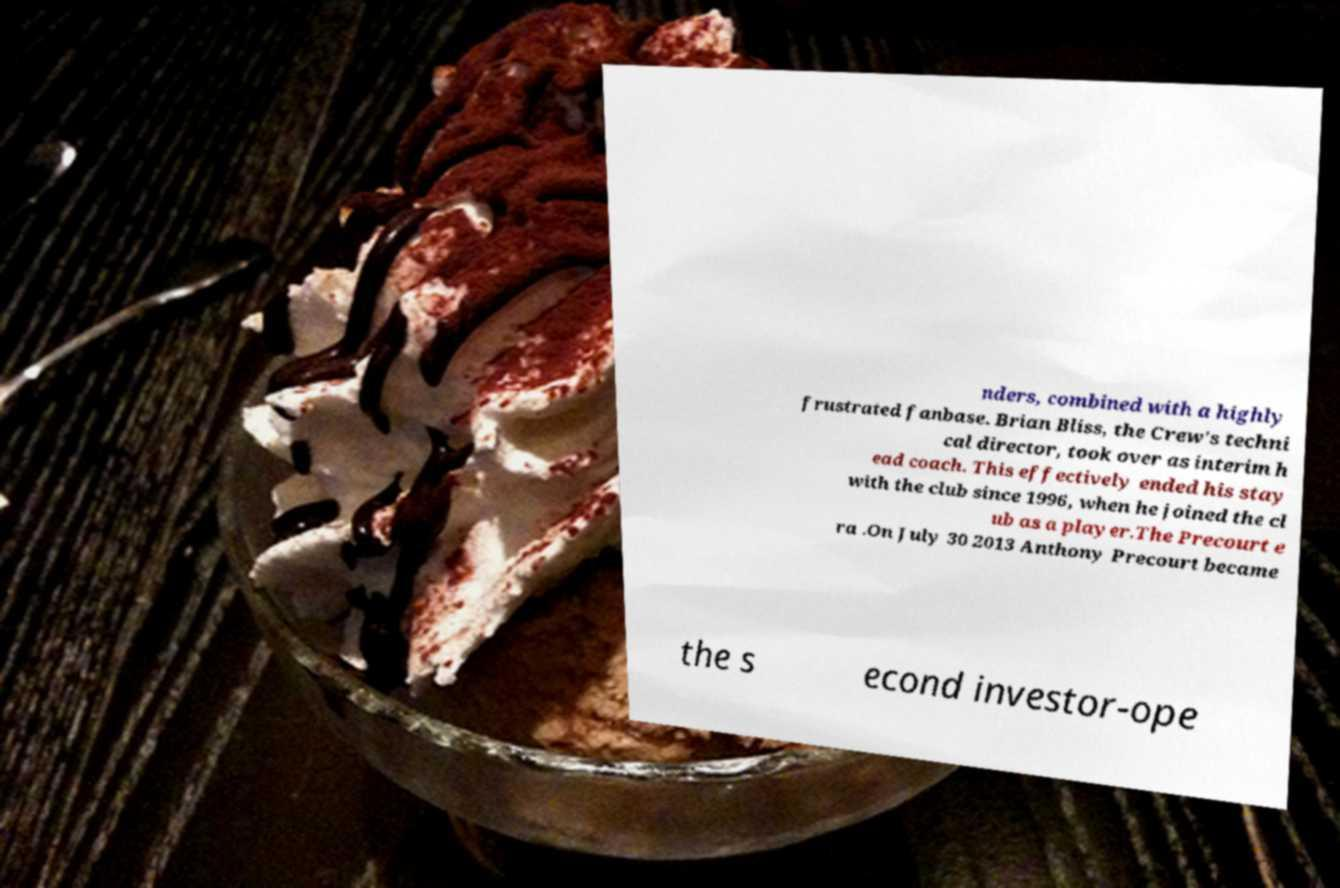Please identify and transcribe the text found in this image. nders, combined with a highly frustrated fanbase. Brian Bliss, the Crew's techni cal director, took over as interim h ead coach. This effectively ended his stay with the club since 1996, when he joined the cl ub as a player.The Precourt e ra .On July 30 2013 Anthony Precourt became the s econd investor-ope 